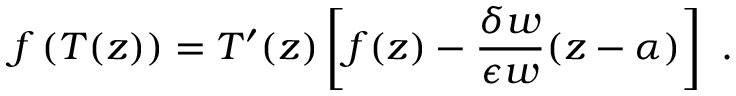<formula> <loc_0><loc_0><loc_500><loc_500>f \left ( T ( z ) \right ) = T ^ { \prime } ( z ) \left [ f ( z ) - \frac { \delta w } { \epsilon w } ( z - \alpha ) \right ] \ .</formula> 